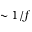Convert formula to latex. <formula><loc_0><loc_0><loc_500><loc_500>\sim 1 / f</formula> 